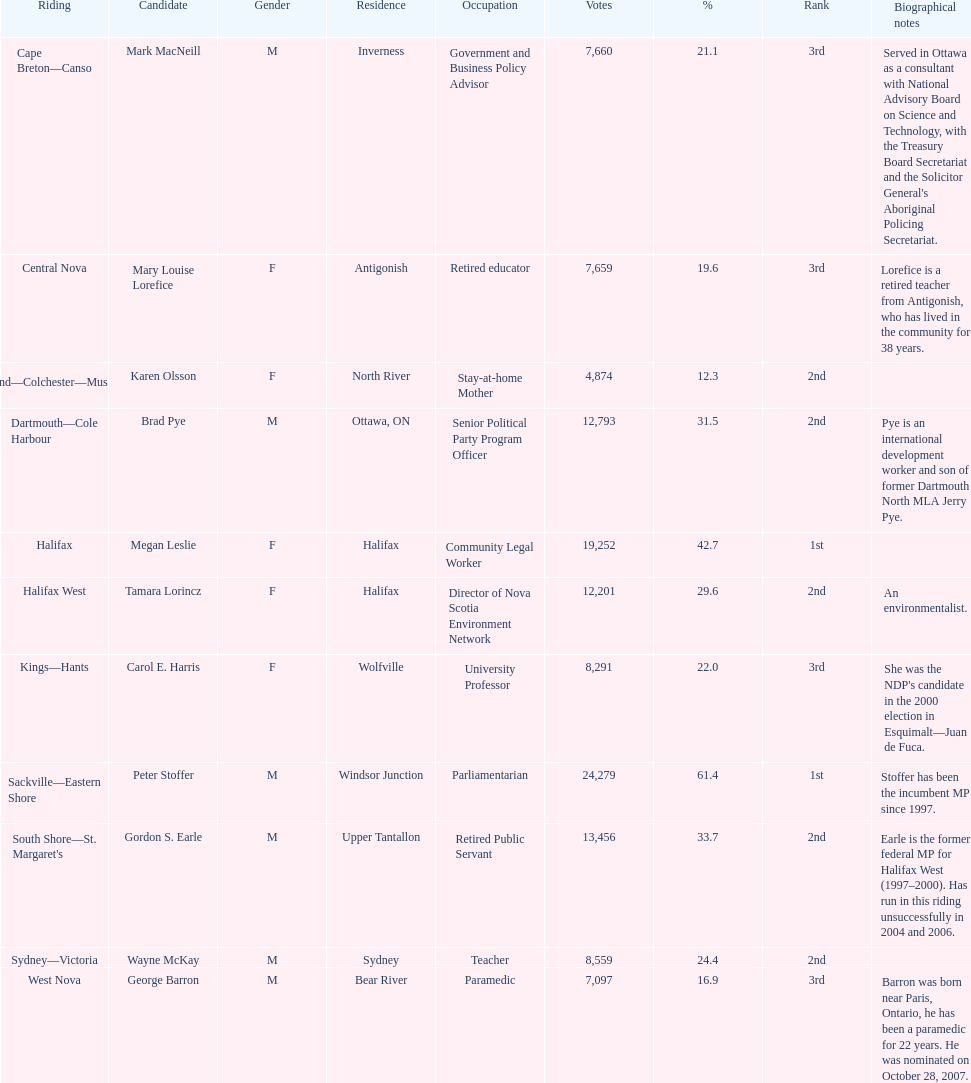How many candidates were women? 5. 